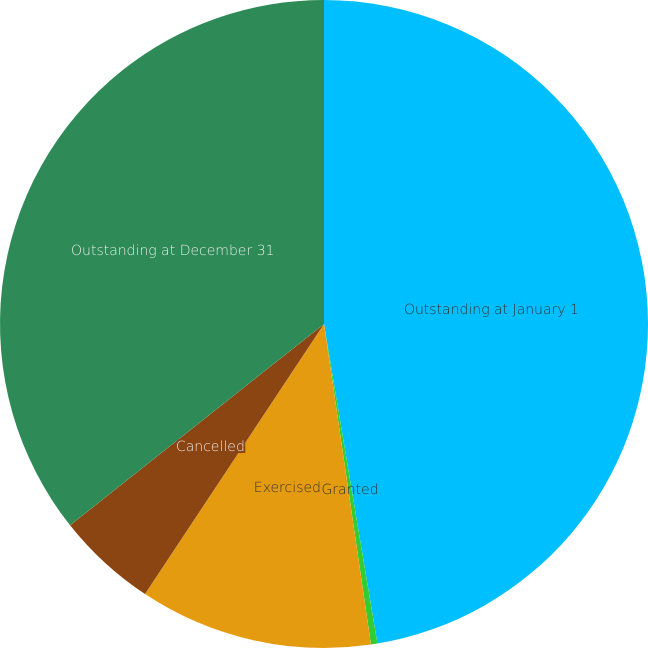Convert chart. <chart><loc_0><loc_0><loc_500><loc_500><pie_chart><fcel>Outstanding at January 1<fcel>Granted<fcel>Exercised<fcel>Cancelled<fcel>Outstanding at December 31<nl><fcel>47.37%<fcel>0.32%<fcel>11.63%<fcel>5.02%<fcel>35.67%<nl></chart> 